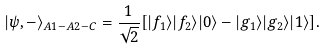<formula> <loc_0><loc_0><loc_500><loc_500>| \psi , - \rangle _ { A 1 - A 2 - C } = \frac { 1 } { \sqrt { 2 } } [ | f _ { 1 } \rangle | f _ { 2 } \rangle | 0 \rangle - | g _ { 1 } \rangle | g _ { 2 } \rangle | 1 \rangle ] .</formula> 